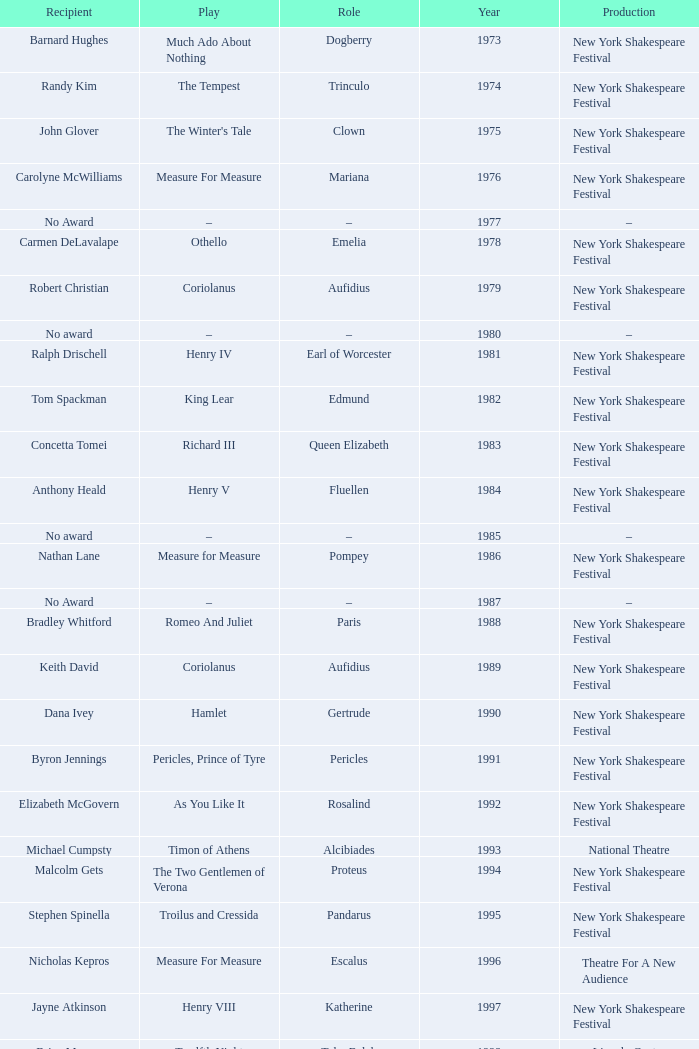Name the recipientof the year for 1976 Carolyne McWilliams. 